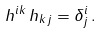Convert formula to latex. <formula><loc_0><loc_0><loc_500><loc_500>h ^ { i k } \, h _ { k j } = \delta _ { j } ^ { i } \, .</formula> 